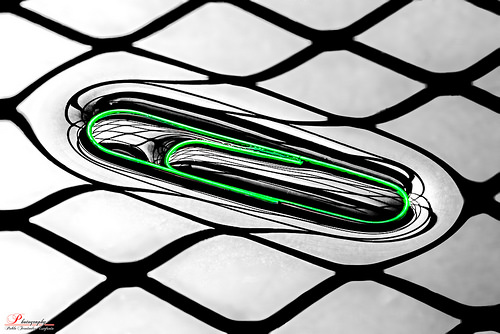<image>
Can you confirm if the paper clip is in the basket? Yes. The paper clip is contained within or inside the basket, showing a containment relationship. 